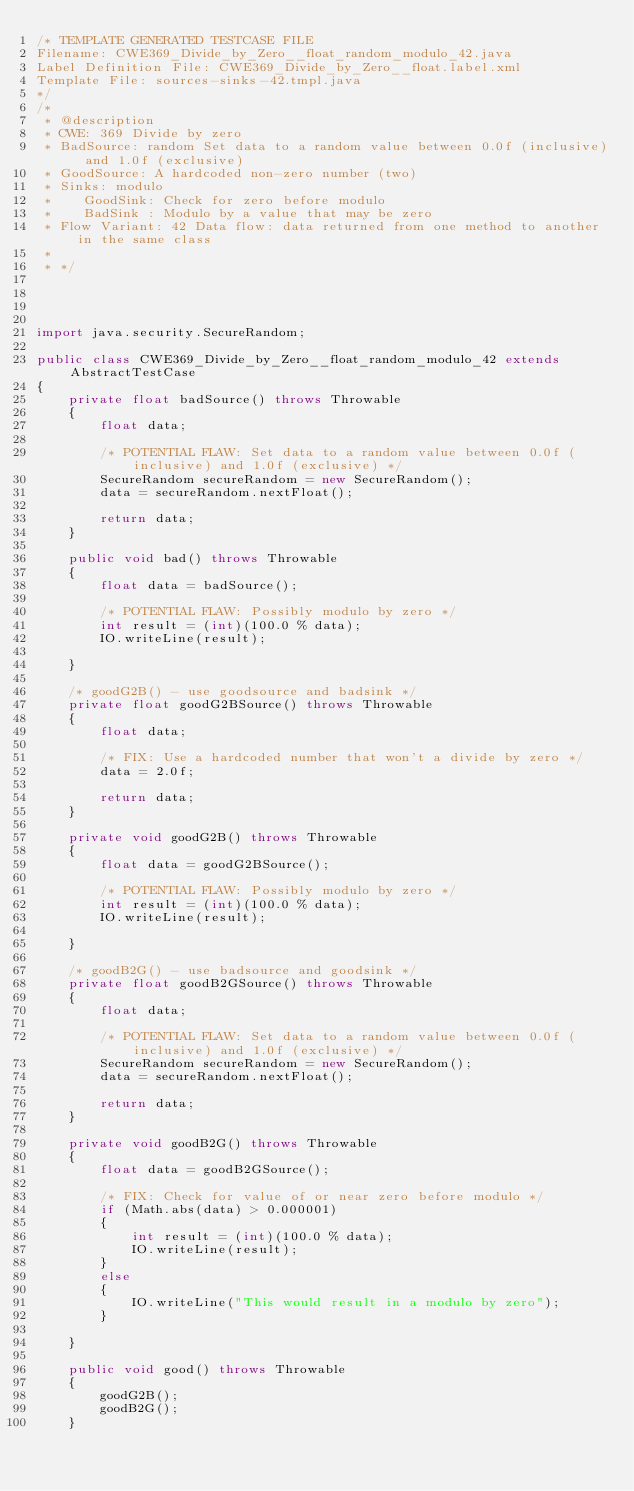Convert code to text. <code><loc_0><loc_0><loc_500><loc_500><_Java_>/* TEMPLATE GENERATED TESTCASE FILE
Filename: CWE369_Divide_by_Zero__float_random_modulo_42.java
Label Definition File: CWE369_Divide_by_Zero__float.label.xml
Template File: sources-sinks-42.tmpl.java
*/
/*
 * @description
 * CWE: 369 Divide by zero
 * BadSource: random Set data to a random value between 0.0f (inclusive) and 1.0f (exclusive)
 * GoodSource: A hardcoded non-zero number (two)
 * Sinks: modulo
 *    GoodSink: Check for zero before modulo
 *    BadSink : Modulo by a value that may be zero
 * Flow Variant: 42 Data flow: data returned from one method to another in the same class
 *
 * */




import java.security.SecureRandom;

public class CWE369_Divide_by_Zero__float_random_modulo_42 extends AbstractTestCase
{
    private float badSource() throws Throwable
    {
        float data;

        /* POTENTIAL FLAW: Set data to a random value between 0.0f (inclusive) and 1.0f (exclusive) */
        SecureRandom secureRandom = new SecureRandom();
        data = secureRandom.nextFloat();

        return data;
    }

    public void bad() throws Throwable
    {
        float data = badSource();

        /* POTENTIAL FLAW: Possibly modulo by zero */
        int result = (int)(100.0 % data);
        IO.writeLine(result);

    }

    /* goodG2B() - use goodsource and badsink */
    private float goodG2BSource() throws Throwable
    {
        float data;

        /* FIX: Use a hardcoded number that won't a divide by zero */
        data = 2.0f;

        return data;
    }

    private void goodG2B() throws Throwable
    {
        float data = goodG2BSource();

        /* POTENTIAL FLAW: Possibly modulo by zero */
        int result = (int)(100.0 % data);
        IO.writeLine(result);

    }

    /* goodB2G() - use badsource and goodsink */
    private float goodB2GSource() throws Throwable
    {
        float data;

        /* POTENTIAL FLAW: Set data to a random value between 0.0f (inclusive) and 1.0f (exclusive) */
        SecureRandom secureRandom = new SecureRandom();
        data = secureRandom.nextFloat();

        return data;
    }

    private void goodB2G() throws Throwable
    {
        float data = goodB2GSource();

        /* FIX: Check for value of or near zero before modulo */
        if (Math.abs(data) > 0.000001)
        {
            int result = (int)(100.0 % data);
            IO.writeLine(result);
        }
        else
        {
            IO.writeLine("This would result in a modulo by zero");
        }

    }

    public void good() throws Throwable
    {
        goodG2B();
        goodB2G();
    }
</code> 